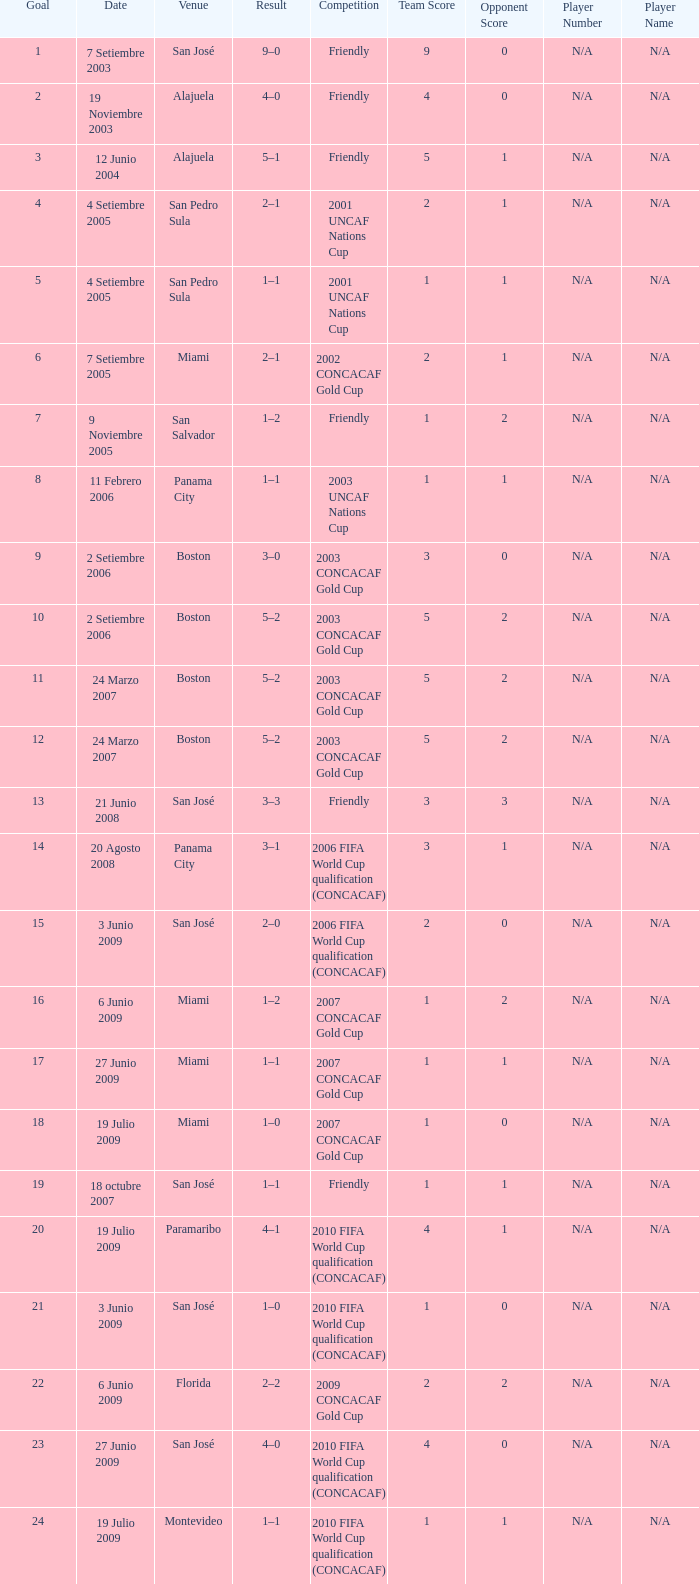How many goals were scored on 21 Junio 2008? 1.0. 